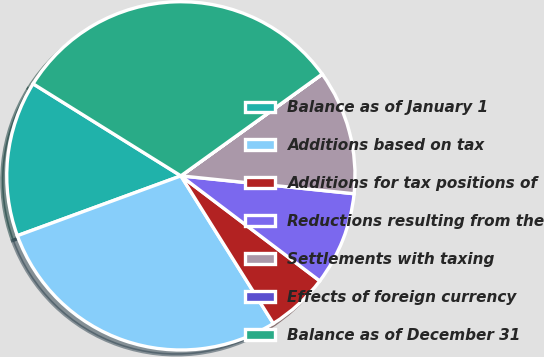<chart> <loc_0><loc_0><loc_500><loc_500><pie_chart><fcel>Balance as of January 1<fcel>Additions based on tax<fcel>Additions for tax positions of<fcel>Reductions resulting from the<fcel>Settlements with taxing<fcel>Effects of foreign currency<fcel>Balance as of December 31<nl><fcel>14.45%<fcel>28.32%<fcel>5.79%<fcel>8.67%<fcel>11.56%<fcel>0.01%<fcel>31.2%<nl></chart> 